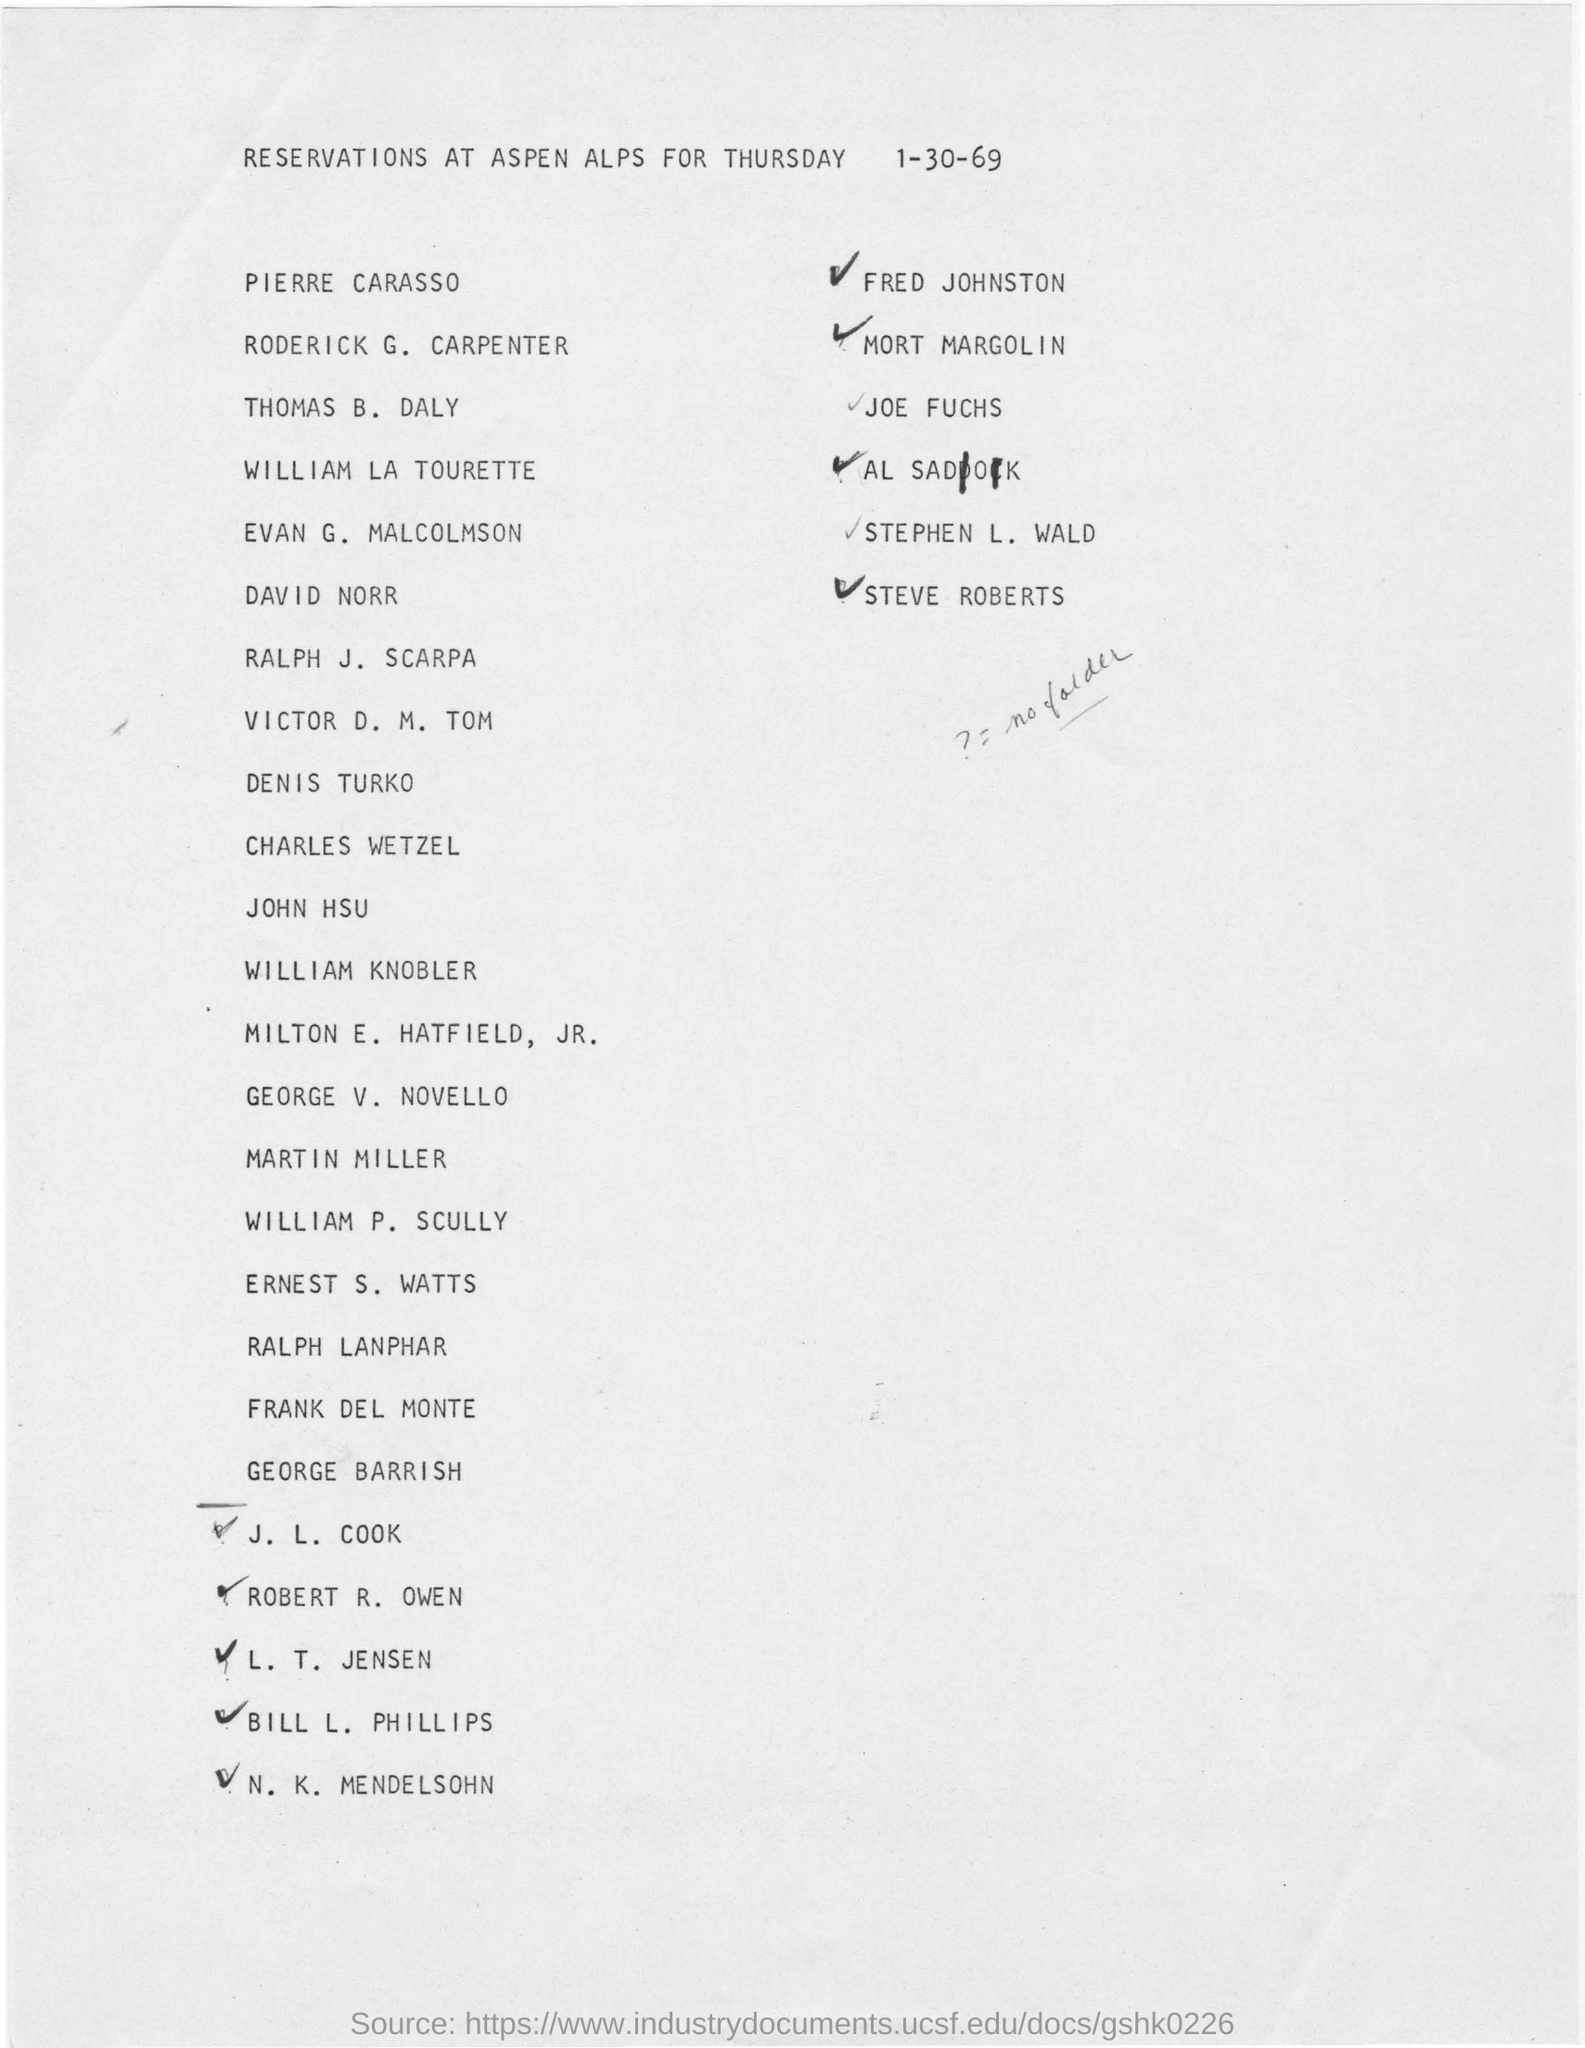For which day are the reservations made?
Provide a succinct answer. Thursday 1-30-69. 